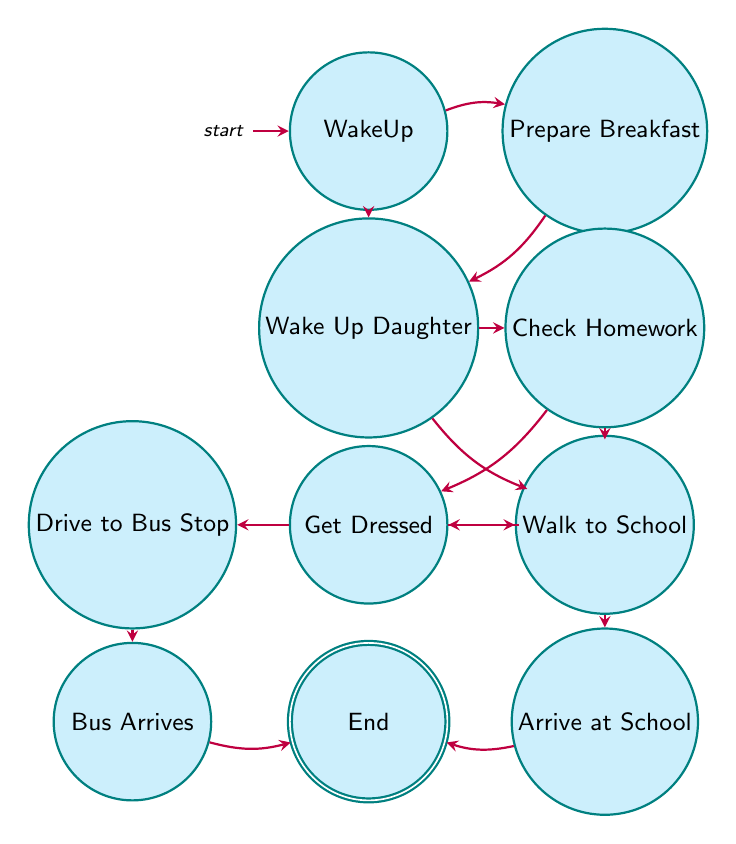What's the first state in the morning routine? The first state in the diagram, where the mother wakes up and checks on her daughter, is labeled "WakeUp." This is indicated as the initial node of the finite state machine.
Answer: WakeUp How many states are there in total? To find the total number of states, we can count each unique node in the diagram. There are 10 nodes present: WakeUp, PrepareBreakfast, WakeUpDaughter, CheckHomework, PrepareLunch, GetDressed, DriveToBusStop, WalkToSchool, BusArrives, ArriveAtSchool, and End.
Answer: 10 From "CheckHomework," what are the possible next states? The diagram shows that from the state "CheckHomework," there are two transitions directed towards two states: "PrepareLunch" and "GetDressed." Both of these are the potential next steps after checking the homework.
Answer: PrepareLunch, GetDressed What is the final state in the morning routine? The final state in the diagram, which indicates the conclusion of the morning routine, is labeled "End." This is the last node where the transitions lead after completing the earlier states.
Answer: End Which state leads to "BusArrives"? In the diagram, the state "DriveToBusStop" leads directly to "BusArrives." This path represents the action of driving the daughter to the bus stop, where the bus arrives afterward.
Answer: DriveToBusStop What are the two exit states from "GetDressed"? The state "GetDressed" has two outgoing transitions represented by arrows pointing toward "DriveToBusStop" and "WalkToSchool." This indicates that after both mother and daughter get dressed, they can either drive to the bus stop or walk to school.
Answer: DriveToBusStop, WalkToSchool Which state comes directly after "ArriveAtSchool"? The diagram shows that after reaching the state "ArriveAtSchool," the next and final transition leads to the state "End." This indicates that the morning routine concludes once the daughter has arrived at school.
Answer: End How many transitions are there in total? To determine the total number of transitions, we can count the directed edges connecting the states in the diagram. There are 13 transitions represented by arrows leading from one state to another.
Answer: 13 